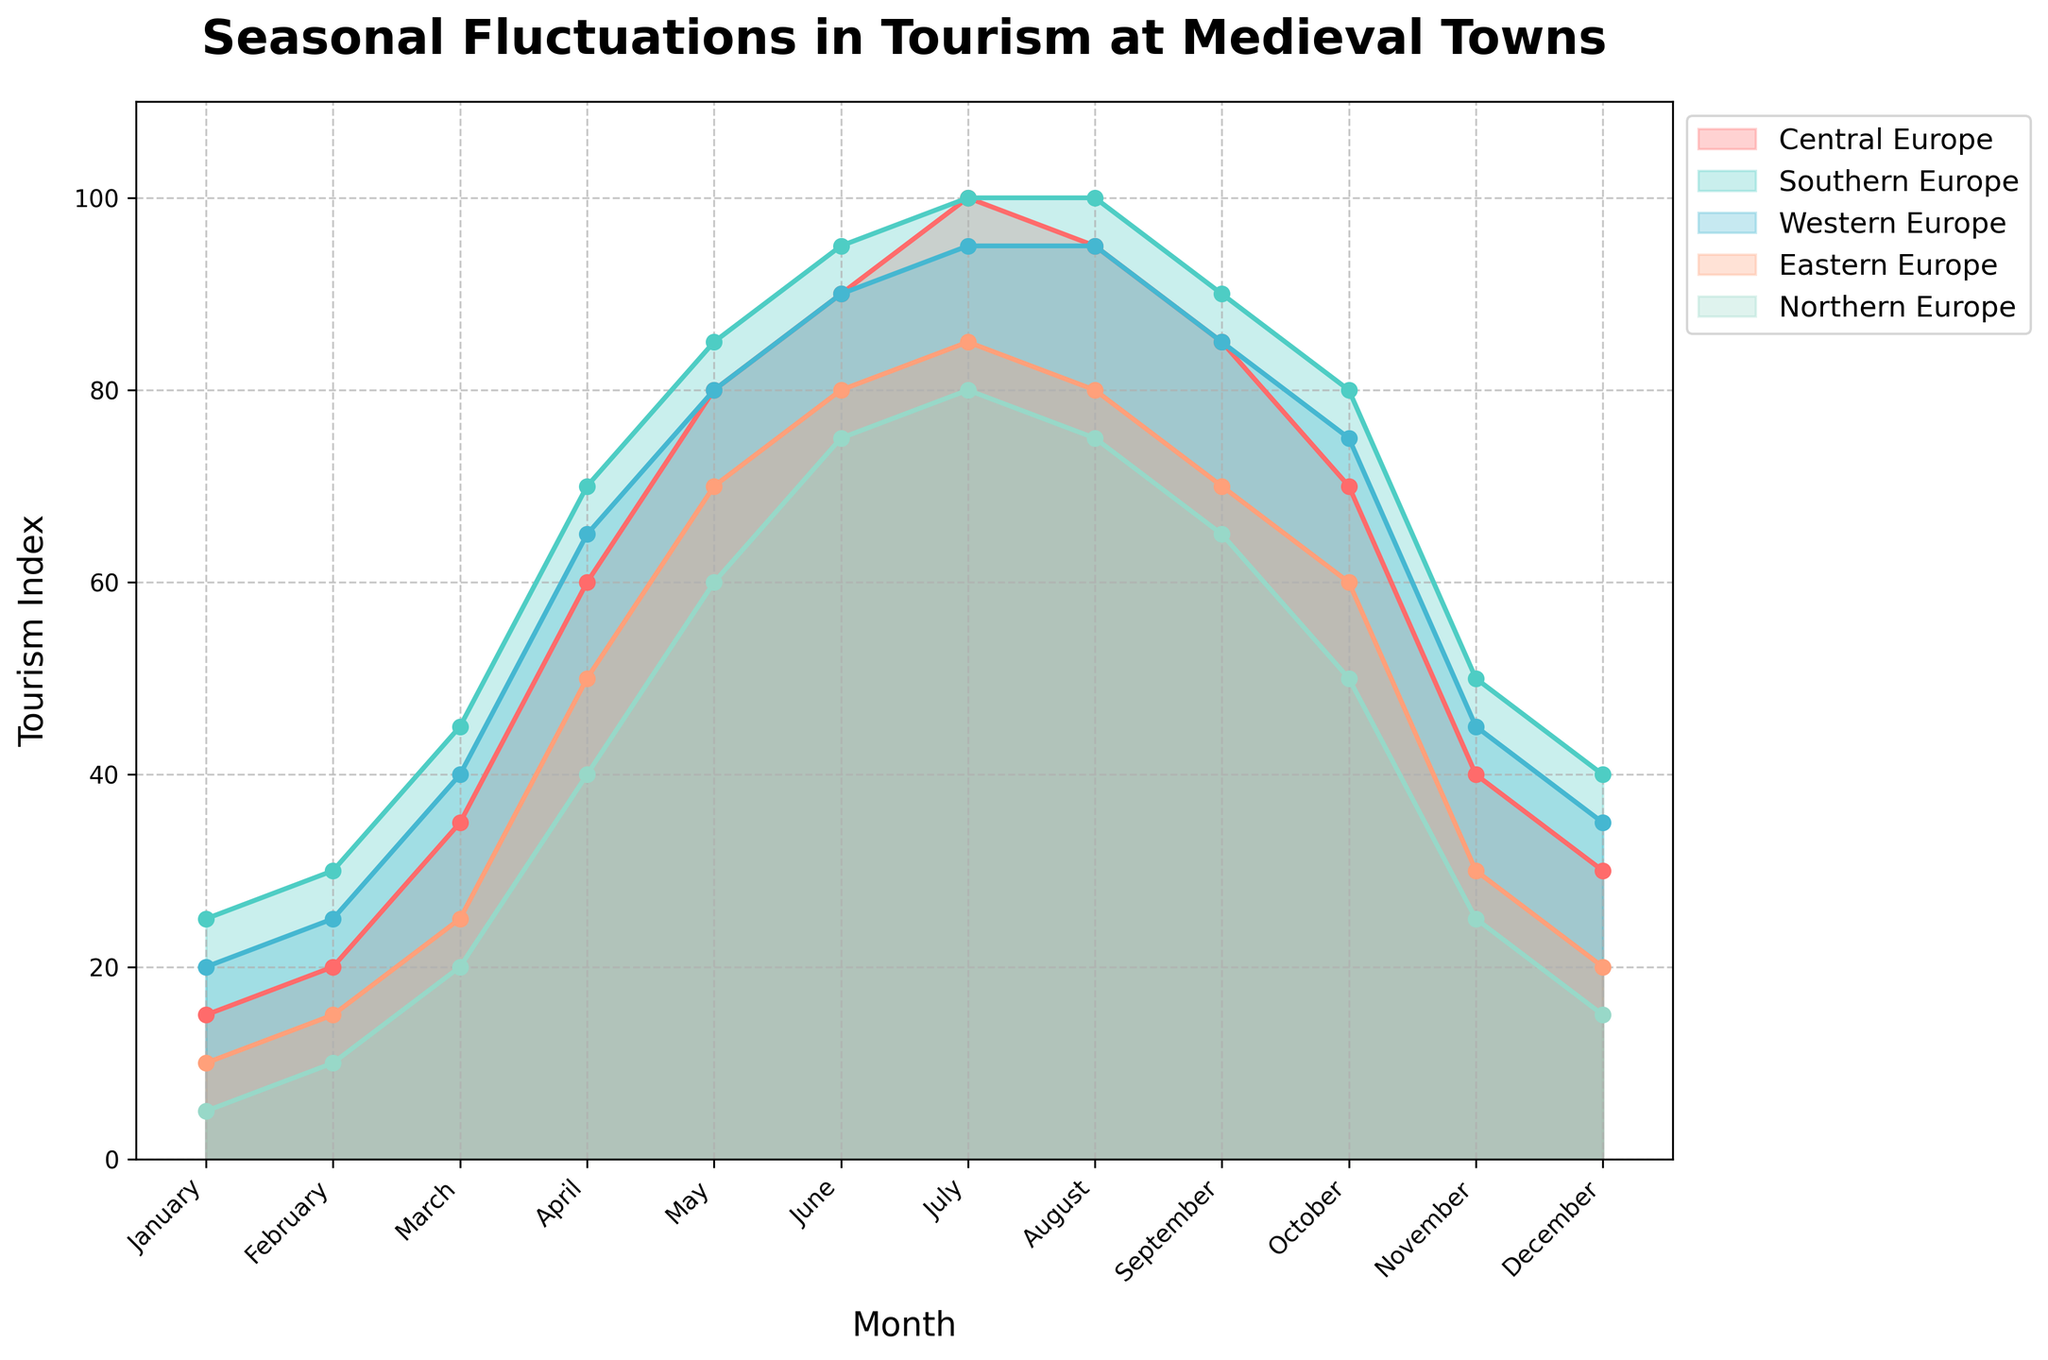What is the title of the chart? The title is located at the top of the chart in bold and larger font size. It's meant to give a clear description of what the chart represents.
Answer: Seasonal Fluctuations in Tourism at Medieval Towns Which region shows the highest tourism index in July? Identify the line that reaches the highest point in July. Each region is represented by a line with distinct colors and markers.
Answer: Southern Europe How does tourism in Western Europe change from January to December? Trace the line representing Western Europe from January to December, noting how the values increase and decrease.
Answer: It starts at 20 in January, peaks in July at 95, and drops to 35 in December Which month experiences the lowest tourism index in Northern Europe, and what is the value? Find the lowest point on the Northern Europe line across all months. The value and month at this point will answer the question.
Answer: January, 5 What is the difference in tourism index between Central Europe and Eastern Europe in March? Locate March on the x-axis, then find the values for both Central Europe and Eastern Europe in this month. Subtract the Eastern Europe value from the Central Europe value.
Answer: 35 - 25 = 10 In which month does Southern Europe see its peak tourism index, and what is the value? Track the Southern Europe line to find its highest point, then identify the corresponding month and value.
Answer: July, 100 Compare the tourism indices in Central Europe and Northern Europe in April. Which one is higher? Check the values for both Central Europe and Northern Europe in April. Compare these two values directly.
Answer: Central Europe (60) is higher than Northern Europe (40) What is the average tourism index of Eastern Europe over the months of June, July, and August? Add the tourism indices for Eastern Europe in June, July, and August, then divide the sum by 3 to find the average.
Answer: (80 + 85 + 80) / 3 = 245 / 3 = 81.67 Which region shows the most significant decrease in tourism index from August to September? Observe the lines between August and September for each region and identify which one has the largest drop in values.
Answer: Southern Europe What is the cumulative tourism index for Central Europe in all months? Sum up all the tourism indices for Central Europe from January to December.
Answer: 15 + 20 + 35 + 60 + 80 + 90 + 100 + 95 + 85 + 70 + 40 + 30 = 720 